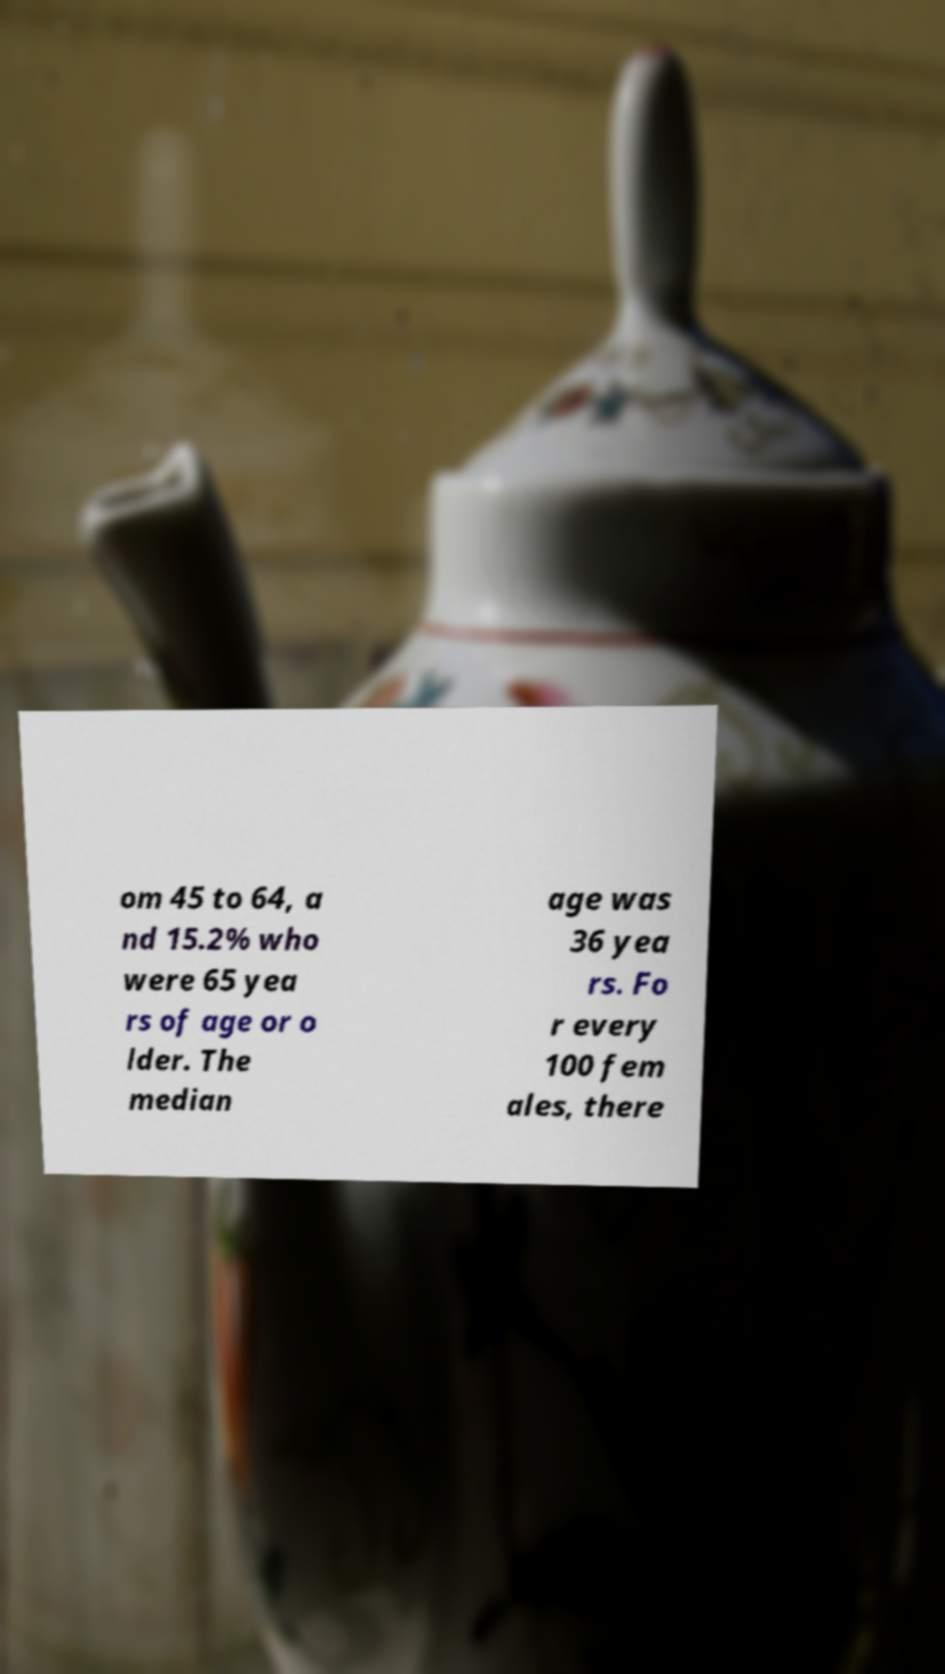What messages or text are displayed in this image? I need them in a readable, typed format. om 45 to 64, a nd 15.2% who were 65 yea rs of age or o lder. The median age was 36 yea rs. Fo r every 100 fem ales, there 